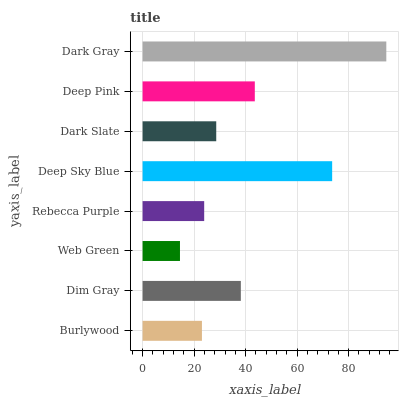Is Web Green the minimum?
Answer yes or no. Yes. Is Dark Gray the maximum?
Answer yes or no. Yes. Is Dim Gray the minimum?
Answer yes or no. No. Is Dim Gray the maximum?
Answer yes or no. No. Is Dim Gray greater than Burlywood?
Answer yes or no. Yes. Is Burlywood less than Dim Gray?
Answer yes or no. Yes. Is Burlywood greater than Dim Gray?
Answer yes or no. No. Is Dim Gray less than Burlywood?
Answer yes or no. No. Is Dim Gray the high median?
Answer yes or no. Yes. Is Dark Slate the low median?
Answer yes or no. Yes. Is Web Green the high median?
Answer yes or no. No. Is Dim Gray the low median?
Answer yes or no. No. 